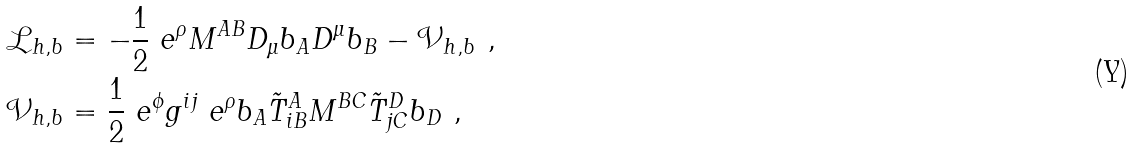<formula> <loc_0><loc_0><loc_500><loc_500>\mathcal { L } _ { h , b } & = - \frac { 1 } { 2 } \ e ^ { \rho } M ^ { A B } D _ { \mu } b _ { A } D ^ { \mu } b _ { B } - \mathcal { V } _ { h , b } \ , \\ \mathcal { V } _ { h , b } & = \frac { 1 } { 2 } \ e ^ { \phi } g ^ { i j } \ e ^ { \rho } b _ { A } { \tilde { T } } ^ { A } _ { i B } { M ^ { B C } } { \tilde { T } } ^ { D } _ { j C } b _ { D } \ ,</formula> 